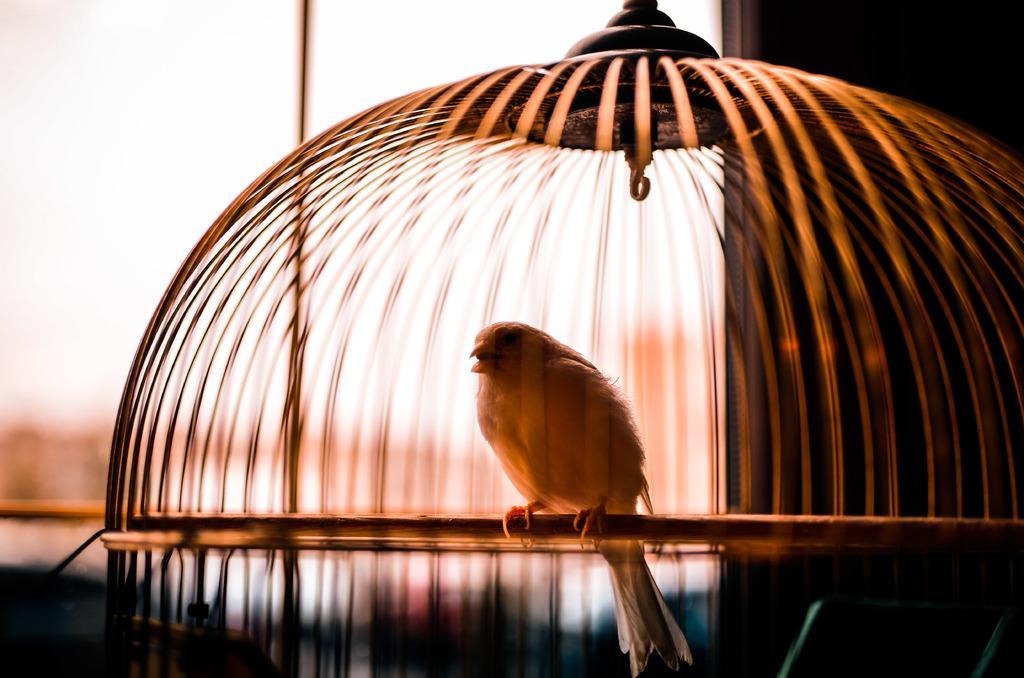Please provide a concise description of this image. In this image I can see the bird inside the net. The net is in brown color and there is a blurred background. 